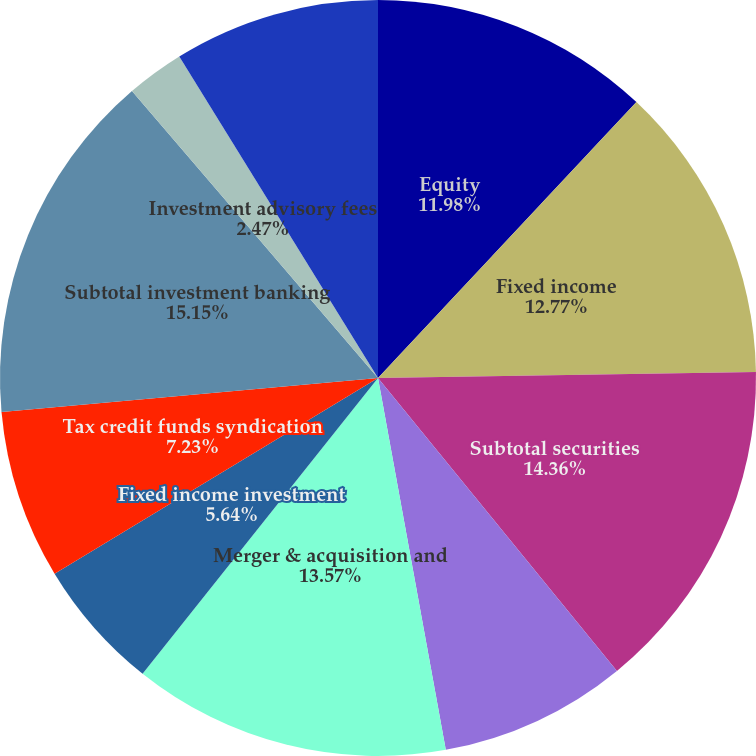Convert chart. <chart><loc_0><loc_0><loc_500><loc_500><pie_chart><fcel>Equity<fcel>Fixed income<fcel>Subtotal securities<fcel>Equity underwriting fees<fcel>Merger & acquisition and<fcel>Fixed income investment<fcel>Tax credit funds syndication<fcel>Subtotal investment banking<fcel>Investment advisory fees<fcel>Net trading profit<nl><fcel>11.98%<fcel>12.77%<fcel>14.36%<fcel>8.02%<fcel>13.57%<fcel>5.64%<fcel>7.23%<fcel>15.15%<fcel>2.47%<fcel>8.81%<nl></chart> 